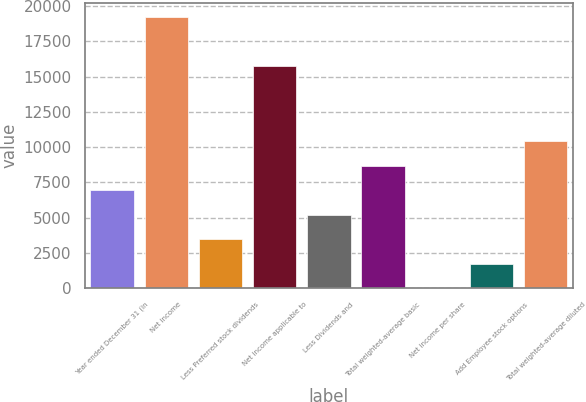Convert chart to OTSL. <chart><loc_0><loc_0><loc_500><loc_500><bar_chart><fcel>Year ended December 31 (in<fcel>Net income<fcel>Less Preferred stock dividends<fcel>Net income applicable to<fcel>Less Dividends and<fcel>Total weighted-average basic<fcel>Net income per share<fcel>Add Employee stock options<fcel>Total weighted-average diluted<nl><fcel>6950.38<fcel>19237.2<fcel>3477.18<fcel>15764<fcel>5213.78<fcel>8686.98<fcel>3.98<fcel>1740.58<fcel>10423.6<nl></chart> 